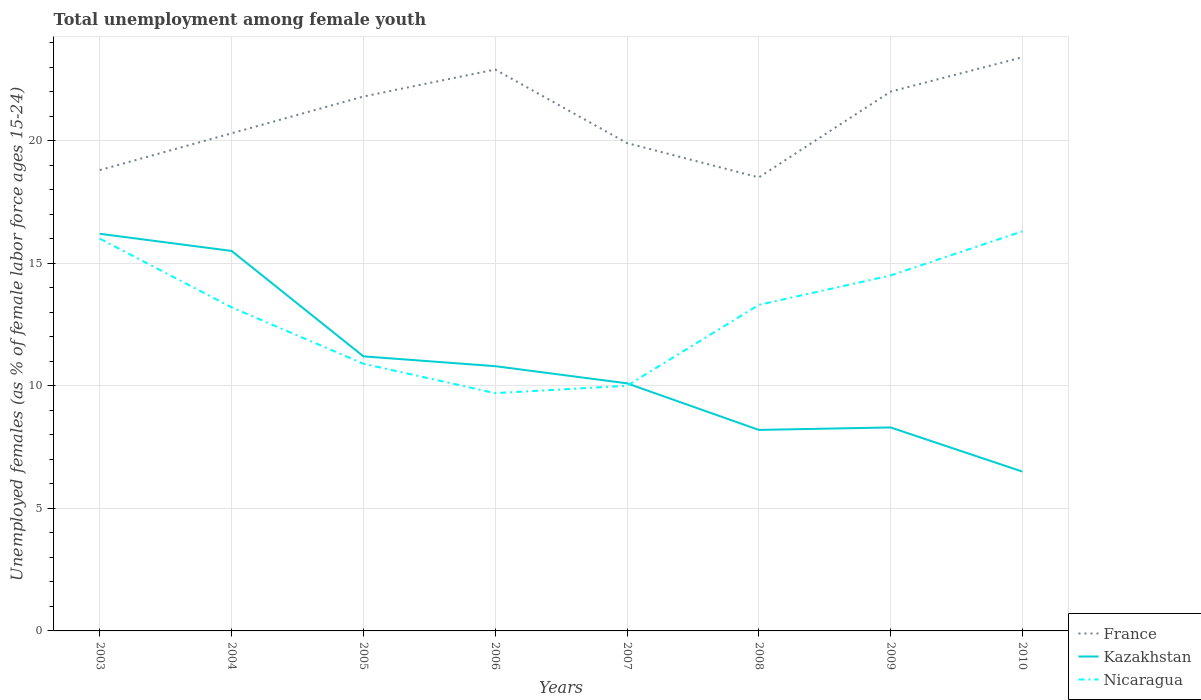How many different coloured lines are there?
Give a very brief answer. 3. In which year was the percentage of unemployed females in in Kazakhstan maximum?
Keep it short and to the point. 2010. What is the total percentage of unemployed females in in Kazakhstan in the graph?
Provide a succinct answer. 3.6. What is the difference between the highest and the second highest percentage of unemployed females in in Nicaragua?
Provide a short and direct response. 6.6. Is the percentage of unemployed females in in Nicaragua strictly greater than the percentage of unemployed females in in Kazakhstan over the years?
Make the answer very short. No. How many lines are there?
Keep it short and to the point. 3. How many years are there in the graph?
Provide a short and direct response. 8. What is the difference between two consecutive major ticks on the Y-axis?
Your answer should be compact. 5. How many legend labels are there?
Your response must be concise. 3. How are the legend labels stacked?
Provide a succinct answer. Vertical. What is the title of the graph?
Provide a succinct answer. Total unemployment among female youth. Does "High income: nonOECD" appear as one of the legend labels in the graph?
Offer a terse response. No. What is the label or title of the X-axis?
Offer a very short reply. Years. What is the label or title of the Y-axis?
Provide a succinct answer. Unemployed females (as % of female labor force ages 15-24). What is the Unemployed females (as % of female labor force ages 15-24) in France in 2003?
Offer a very short reply. 18.8. What is the Unemployed females (as % of female labor force ages 15-24) of Kazakhstan in 2003?
Keep it short and to the point. 16.2. What is the Unemployed females (as % of female labor force ages 15-24) in Nicaragua in 2003?
Your answer should be compact. 16. What is the Unemployed females (as % of female labor force ages 15-24) in France in 2004?
Your response must be concise. 20.3. What is the Unemployed females (as % of female labor force ages 15-24) in Nicaragua in 2004?
Your answer should be compact. 13.2. What is the Unemployed females (as % of female labor force ages 15-24) in France in 2005?
Offer a very short reply. 21.8. What is the Unemployed females (as % of female labor force ages 15-24) of Kazakhstan in 2005?
Provide a succinct answer. 11.2. What is the Unemployed females (as % of female labor force ages 15-24) of Nicaragua in 2005?
Offer a terse response. 10.9. What is the Unemployed females (as % of female labor force ages 15-24) in France in 2006?
Offer a terse response. 22.9. What is the Unemployed females (as % of female labor force ages 15-24) of Kazakhstan in 2006?
Your response must be concise. 10.8. What is the Unemployed females (as % of female labor force ages 15-24) in Nicaragua in 2006?
Provide a short and direct response. 9.7. What is the Unemployed females (as % of female labor force ages 15-24) of France in 2007?
Give a very brief answer. 19.9. What is the Unemployed females (as % of female labor force ages 15-24) in Kazakhstan in 2007?
Make the answer very short. 10.1. What is the Unemployed females (as % of female labor force ages 15-24) in Nicaragua in 2007?
Your answer should be compact. 10. What is the Unemployed females (as % of female labor force ages 15-24) of France in 2008?
Provide a succinct answer. 18.5. What is the Unemployed females (as % of female labor force ages 15-24) of Kazakhstan in 2008?
Your answer should be compact. 8.2. What is the Unemployed females (as % of female labor force ages 15-24) of Nicaragua in 2008?
Your answer should be very brief. 13.3. What is the Unemployed females (as % of female labor force ages 15-24) of France in 2009?
Provide a succinct answer. 22. What is the Unemployed females (as % of female labor force ages 15-24) of Kazakhstan in 2009?
Your answer should be compact. 8.3. What is the Unemployed females (as % of female labor force ages 15-24) in Nicaragua in 2009?
Your answer should be compact. 14.5. What is the Unemployed females (as % of female labor force ages 15-24) in France in 2010?
Provide a succinct answer. 23.4. What is the Unemployed females (as % of female labor force ages 15-24) of Nicaragua in 2010?
Offer a terse response. 16.3. Across all years, what is the maximum Unemployed females (as % of female labor force ages 15-24) of France?
Your response must be concise. 23.4. Across all years, what is the maximum Unemployed females (as % of female labor force ages 15-24) of Kazakhstan?
Make the answer very short. 16.2. Across all years, what is the maximum Unemployed females (as % of female labor force ages 15-24) in Nicaragua?
Your answer should be very brief. 16.3. Across all years, what is the minimum Unemployed females (as % of female labor force ages 15-24) of Kazakhstan?
Your answer should be compact. 6.5. Across all years, what is the minimum Unemployed females (as % of female labor force ages 15-24) in Nicaragua?
Provide a short and direct response. 9.7. What is the total Unemployed females (as % of female labor force ages 15-24) in France in the graph?
Keep it short and to the point. 167.6. What is the total Unemployed females (as % of female labor force ages 15-24) in Kazakhstan in the graph?
Your answer should be compact. 86.8. What is the total Unemployed females (as % of female labor force ages 15-24) in Nicaragua in the graph?
Your response must be concise. 103.9. What is the difference between the Unemployed females (as % of female labor force ages 15-24) of France in 2003 and that in 2004?
Make the answer very short. -1.5. What is the difference between the Unemployed females (as % of female labor force ages 15-24) of Nicaragua in 2003 and that in 2006?
Your answer should be compact. 6.3. What is the difference between the Unemployed females (as % of female labor force ages 15-24) of France in 2003 and that in 2007?
Provide a succinct answer. -1.1. What is the difference between the Unemployed females (as % of female labor force ages 15-24) of Nicaragua in 2003 and that in 2008?
Offer a very short reply. 2.7. What is the difference between the Unemployed females (as % of female labor force ages 15-24) of Kazakhstan in 2003 and that in 2009?
Your answer should be very brief. 7.9. What is the difference between the Unemployed females (as % of female labor force ages 15-24) of Kazakhstan in 2003 and that in 2010?
Ensure brevity in your answer.  9.7. What is the difference between the Unemployed females (as % of female labor force ages 15-24) in France in 2004 and that in 2005?
Ensure brevity in your answer.  -1.5. What is the difference between the Unemployed females (as % of female labor force ages 15-24) in Kazakhstan in 2004 and that in 2005?
Offer a very short reply. 4.3. What is the difference between the Unemployed females (as % of female labor force ages 15-24) of Nicaragua in 2004 and that in 2005?
Keep it short and to the point. 2.3. What is the difference between the Unemployed females (as % of female labor force ages 15-24) of Nicaragua in 2004 and that in 2006?
Give a very brief answer. 3.5. What is the difference between the Unemployed females (as % of female labor force ages 15-24) in France in 2004 and that in 2007?
Your answer should be very brief. 0.4. What is the difference between the Unemployed females (as % of female labor force ages 15-24) in Nicaragua in 2004 and that in 2007?
Provide a short and direct response. 3.2. What is the difference between the Unemployed females (as % of female labor force ages 15-24) of France in 2004 and that in 2008?
Ensure brevity in your answer.  1.8. What is the difference between the Unemployed females (as % of female labor force ages 15-24) in Kazakhstan in 2004 and that in 2009?
Provide a succinct answer. 7.2. What is the difference between the Unemployed females (as % of female labor force ages 15-24) in Kazakhstan in 2005 and that in 2006?
Provide a short and direct response. 0.4. What is the difference between the Unemployed females (as % of female labor force ages 15-24) of Nicaragua in 2005 and that in 2006?
Provide a succinct answer. 1.2. What is the difference between the Unemployed females (as % of female labor force ages 15-24) in Kazakhstan in 2005 and that in 2008?
Keep it short and to the point. 3. What is the difference between the Unemployed females (as % of female labor force ages 15-24) in Nicaragua in 2005 and that in 2008?
Offer a very short reply. -2.4. What is the difference between the Unemployed females (as % of female labor force ages 15-24) of Kazakhstan in 2005 and that in 2009?
Give a very brief answer. 2.9. What is the difference between the Unemployed females (as % of female labor force ages 15-24) in Nicaragua in 2005 and that in 2009?
Give a very brief answer. -3.6. What is the difference between the Unemployed females (as % of female labor force ages 15-24) of Kazakhstan in 2006 and that in 2007?
Give a very brief answer. 0.7. What is the difference between the Unemployed females (as % of female labor force ages 15-24) of France in 2006 and that in 2008?
Provide a short and direct response. 4.4. What is the difference between the Unemployed females (as % of female labor force ages 15-24) in Kazakhstan in 2006 and that in 2008?
Your response must be concise. 2.6. What is the difference between the Unemployed females (as % of female labor force ages 15-24) in Nicaragua in 2006 and that in 2008?
Provide a succinct answer. -3.6. What is the difference between the Unemployed females (as % of female labor force ages 15-24) of Kazakhstan in 2006 and that in 2010?
Provide a succinct answer. 4.3. What is the difference between the Unemployed females (as % of female labor force ages 15-24) in France in 2007 and that in 2009?
Provide a short and direct response. -2.1. What is the difference between the Unemployed females (as % of female labor force ages 15-24) in Kazakhstan in 2007 and that in 2009?
Your response must be concise. 1.8. What is the difference between the Unemployed females (as % of female labor force ages 15-24) in Nicaragua in 2007 and that in 2009?
Make the answer very short. -4.5. What is the difference between the Unemployed females (as % of female labor force ages 15-24) of France in 2007 and that in 2010?
Provide a short and direct response. -3.5. What is the difference between the Unemployed females (as % of female labor force ages 15-24) of France in 2008 and that in 2009?
Provide a succinct answer. -3.5. What is the difference between the Unemployed females (as % of female labor force ages 15-24) in Nicaragua in 2008 and that in 2009?
Your answer should be very brief. -1.2. What is the difference between the Unemployed females (as % of female labor force ages 15-24) of Nicaragua in 2008 and that in 2010?
Offer a terse response. -3. What is the difference between the Unemployed females (as % of female labor force ages 15-24) in Nicaragua in 2009 and that in 2010?
Your response must be concise. -1.8. What is the difference between the Unemployed females (as % of female labor force ages 15-24) of France in 2003 and the Unemployed females (as % of female labor force ages 15-24) of Kazakhstan in 2005?
Your answer should be very brief. 7.6. What is the difference between the Unemployed females (as % of female labor force ages 15-24) in Kazakhstan in 2003 and the Unemployed females (as % of female labor force ages 15-24) in Nicaragua in 2005?
Your answer should be compact. 5.3. What is the difference between the Unemployed females (as % of female labor force ages 15-24) in France in 2003 and the Unemployed females (as % of female labor force ages 15-24) in Kazakhstan in 2006?
Provide a short and direct response. 8. What is the difference between the Unemployed females (as % of female labor force ages 15-24) of France in 2003 and the Unemployed females (as % of female labor force ages 15-24) of Nicaragua in 2006?
Give a very brief answer. 9.1. What is the difference between the Unemployed females (as % of female labor force ages 15-24) in France in 2003 and the Unemployed females (as % of female labor force ages 15-24) in Kazakhstan in 2008?
Your answer should be very brief. 10.6. What is the difference between the Unemployed females (as % of female labor force ages 15-24) in France in 2003 and the Unemployed females (as % of female labor force ages 15-24) in Kazakhstan in 2009?
Your answer should be very brief. 10.5. What is the difference between the Unemployed females (as % of female labor force ages 15-24) of France in 2004 and the Unemployed females (as % of female labor force ages 15-24) of Nicaragua in 2005?
Keep it short and to the point. 9.4. What is the difference between the Unemployed females (as % of female labor force ages 15-24) in Kazakhstan in 2004 and the Unemployed females (as % of female labor force ages 15-24) in Nicaragua in 2005?
Provide a short and direct response. 4.6. What is the difference between the Unemployed females (as % of female labor force ages 15-24) in France in 2004 and the Unemployed females (as % of female labor force ages 15-24) in Kazakhstan in 2006?
Ensure brevity in your answer.  9.5. What is the difference between the Unemployed females (as % of female labor force ages 15-24) in France in 2004 and the Unemployed females (as % of female labor force ages 15-24) in Nicaragua in 2008?
Provide a short and direct response. 7. What is the difference between the Unemployed females (as % of female labor force ages 15-24) of Kazakhstan in 2004 and the Unemployed females (as % of female labor force ages 15-24) of Nicaragua in 2008?
Keep it short and to the point. 2.2. What is the difference between the Unemployed females (as % of female labor force ages 15-24) in France in 2004 and the Unemployed females (as % of female labor force ages 15-24) in Kazakhstan in 2009?
Your answer should be compact. 12. What is the difference between the Unemployed females (as % of female labor force ages 15-24) of France in 2004 and the Unemployed females (as % of female labor force ages 15-24) of Kazakhstan in 2010?
Make the answer very short. 13.8. What is the difference between the Unemployed females (as % of female labor force ages 15-24) of France in 2004 and the Unemployed females (as % of female labor force ages 15-24) of Nicaragua in 2010?
Provide a short and direct response. 4. What is the difference between the Unemployed females (as % of female labor force ages 15-24) in France in 2005 and the Unemployed females (as % of female labor force ages 15-24) in Kazakhstan in 2006?
Ensure brevity in your answer.  11. What is the difference between the Unemployed females (as % of female labor force ages 15-24) in Kazakhstan in 2005 and the Unemployed females (as % of female labor force ages 15-24) in Nicaragua in 2006?
Provide a short and direct response. 1.5. What is the difference between the Unemployed females (as % of female labor force ages 15-24) of Kazakhstan in 2005 and the Unemployed females (as % of female labor force ages 15-24) of Nicaragua in 2007?
Ensure brevity in your answer.  1.2. What is the difference between the Unemployed females (as % of female labor force ages 15-24) of France in 2005 and the Unemployed females (as % of female labor force ages 15-24) of Nicaragua in 2008?
Ensure brevity in your answer.  8.5. What is the difference between the Unemployed females (as % of female labor force ages 15-24) of Kazakhstan in 2005 and the Unemployed females (as % of female labor force ages 15-24) of Nicaragua in 2008?
Your answer should be very brief. -2.1. What is the difference between the Unemployed females (as % of female labor force ages 15-24) of France in 2005 and the Unemployed females (as % of female labor force ages 15-24) of Nicaragua in 2009?
Make the answer very short. 7.3. What is the difference between the Unemployed females (as % of female labor force ages 15-24) of France in 2006 and the Unemployed females (as % of female labor force ages 15-24) of Kazakhstan in 2007?
Offer a terse response. 12.8. What is the difference between the Unemployed females (as % of female labor force ages 15-24) of France in 2006 and the Unemployed females (as % of female labor force ages 15-24) of Nicaragua in 2008?
Make the answer very short. 9.6. What is the difference between the Unemployed females (as % of female labor force ages 15-24) in Kazakhstan in 2006 and the Unemployed females (as % of female labor force ages 15-24) in Nicaragua in 2008?
Offer a terse response. -2.5. What is the difference between the Unemployed females (as % of female labor force ages 15-24) of France in 2006 and the Unemployed females (as % of female labor force ages 15-24) of Nicaragua in 2009?
Make the answer very short. 8.4. What is the difference between the Unemployed females (as % of female labor force ages 15-24) of Kazakhstan in 2006 and the Unemployed females (as % of female labor force ages 15-24) of Nicaragua in 2009?
Your response must be concise. -3.7. What is the difference between the Unemployed females (as % of female labor force ages 15-24) of Kazakhstan in 2006 and the Unemployed females (as % of female labor force ages 15-24) of Nicaragua in 2010?
Offer a very short reply. -5.5. What is the difference between the Unemployed females (as % of female labor force ages 15-24) of France in 2007 and the Unemployed females (as % of female labor force ages 15-24) of Nicaragua in 2008?
Your answer should be very brief. 6.6. What is the difference between the Unemployed females (as % of female labor force ages 15-24) in France in 2007 and the Unemployed females (as % of female labor force ages 15-24) in Kazakhstan in 2009?
Ensure brevity in your answer.  11.6. What is the difference between the Unemployed females (as % of female labor force ages 15-24) in France in 2007 and the Unemployed females (as % of female labor force ages 15-24) in Nicaragua in 2010?
Your answer should be very brief. 3.6. What is the difference between the Unemployed females (as % of female labor force ages 15-24) of Kazakhstan in 2008 and the Unemployed females (as % of female labor force ages 15-24) of Nicaragua in 2009?
Your response must be concise. -6.3. What is the difference between the Unemployed females (as % of female labor force ages 15-24) in France in 2008 and the Unemployed females (as % of female labor force ages 15-24) in Kazakhstan in 2010?
Ensure brevity in your answer.  12. What is the difference between the Unemployed females (as % of female labor force ages 15-24) of France in 2009 and the Unemployed females (as % of female labor force ages 15-24) of Nicaragua in 2010?
Provide a short and direct response. 5.7. What is the difference between the Unemployed females (as % of female labor force ages 15-24) of Kazakhstan in 2009 and the Unemployed females (as % of female labor force ages 15-24) of Nicaragua in 2010?
Offer a terse response. -8. What is the average Unemployed females (as % of female labor force ages 15-24) of France per year?
Offer a terse response. 20.95. What is the average Unemployed females (as % of female labor force ages 15-24) of Kazakhstan per year?
Provide a short and direct response. 10.85. What is the average Unemployed females (as % of female labor force ages 15-24) in Nicaragua per year?
Your response must be concise. 12.99. In the year 2003, what is the difference between the Unemployed females (as % of female labor force ages 15-24) of France and Unemployed females (as % of female labor force ages 15-24) of Nicaragua?
Keep it short and to the point. 2.8. In the year 2004, what is the difference between the Unemployed females (as % of female labor force ages 15-24) in France and Unemployed females (as % of female labor force ages 15-24) in Nicaragua?
Your answer should be compact. 7.1. In the year 2005, what is the difference between the Unemployed females (as % of female labor force ages 15-24) of France and Unemployed females (as % of female labor force ages 15-24) of Nicaragua?
Your answer should be compact. 10.9. In the year 2005, what is the difference between the Unemployed females (as % of female labor force ages 15-24) of Kazakhstan and Unemployed females (as % of female labor force ages 15-24) of Nicaragua?
Your answer should be compact. 0.3. In the year 2006, what is the difference between the Unemployed females (as % of female labor force ages 15-24) in Kazakhstan and Unemployed females (as % of female labor force ages 15-24) in Nicaragua?
Keep it short and to the point. 1.1. In the year 2007, what is the difference between the Unemployed females (as % of female labor force ages 15-24) of France and Unemployed females (as % of female labor force ages 15-24) of Nicaragua?
Give a very brief answer. 9.9. In the year 2008, what is the difference between the Unemployed females (as % of female labor force ages 15-24) in France and Unemployed females (as % of female labor force ages 15-24) in Nicaragua?
Keep it short and to the point. 5.2. In the year 2009, what is the difference between the Unemployed females (as % of female labor force ages 15-24) in France and Unemployed females (as % of female labor force ages 15-24) in Kazakhstan?
Offer a terse response. 13.7. In the year 2009, what is the difference between the Unemployed females (as % of female labor force ages 15-24) in Kazakhstan and Unemployed females (as % of female labor force ages 15-24) in Nicaragua?
Keep it short and to the point. -6.2. In the year 2010, what is the difference between the Unemployed females (as % of female labor force ages 15-24) in France and Unemployed females (as % of female labor force ages 15-24) in Kazakhstan?
Make the answer very short. 16.9. In the year 2010, what is the difference between the Unemployed females (as % of female labor force ages 15-24) in France and Unemployed females (as % of female labor force ages 15-24) in Nicaragua?
Make the answer very short. 7.1. In the year 2010, what is the difference between the Unemployed females (as % of female labor force ages 15-24) in Kazakhstan and Unemployed females (as % of female labor force ages 15-24) in Nicaragua?
Your response must be concise. -9.8. What is the ratio of the Unemployed females (as % of female labor force ages 15-24) in France in 2003 to that in 2004?
Provide a short and direct response. 0.93. What is the ratio of the Unemployed females (as % of female labor force ages 15-24) in Kazakhstan in 2003 to that in 2004?
Give a very brief answer. 1.05. What is the ratio of the Unemployed females (as % of female labor force ages 15-24) in Nicaragua in 2003 to that in 2004?
Provide a succinct answer. 1.21. What is the ratio of the Unemployed females (as % of female labor force ages 15-24) in France in 2003 to that in 2005?
Your answer should be very brief. 0.86. What is the ratio of the Unemployed females (as % of female labor force ages 15-24) in Kazakhstan in 2003 to that in 2005?
Make the answer very short. 1.45. What is the ratio of the Unemployed females (as % of female labor force ages 15-24) in Nicaragua in 2003 to that in 2005?
Keep it short and to the point. 1.47. What is the ratio of the Unemployed females (as % of female labor force ages 15-24) in France in 2003 to that in 2006?
Offer a very short reply. 0.82. What is the ratio of the Unemployed females (as % of female labor force ages 15-24) of Nicaragua in 2003 to that in 2006?
Give a very brief answer. 1.65. What is the ratio of the Unemployed females (as % of female labor force ages 15-24) in France in 2003 to that in 2007?
Offer a very short reply. 0.94. What is the ratio of the Unemployed females (as % of female labor force ages 15-24) in Kazakhstan in 2003 to that in 2007?
Your answer should be very brief. 1.6. What is the ratio of the Unemployed females (as % of female labor force ages 15-24) of France in 2003 to that in 2008?
Provide a succinct answer. 1.02. What is the ratio of the Unemployed females (as % of female labor force ages 15-24) of Kazakhstan in 2003 to that in 2008?
Keep it short and to the point. 1.98. What is the ratio of the Unemployed females (as % of female labor force ages 15-24) of Nicaragua in 2003 to that in 2008?
Offer a very short reply. 1.2. What is the ratio of the Unemployed females (as % of female labor force ages 15-24) in France in 2003 to that in 2009?
Keep it short and to the point. 0.85. What is the ratio of the Unemployed females (as % of female labor force ages 15-24) in Kazakhstan in 2003 to that in 2009?
Provide a succinct answer. 1.95. What is the ratio of the Unemployed females (as % of female labor force ages 15-24) of Nicaragua in 2003 to that in 2009?
Offer a very short reply. 1.1. What is the ratio of the Unemployed females (as % of female labor force ages 15-24) in France in 2003 to that in 2010?
Offer a very short reply. 0.8. What is the ratio of the Unemployed females (as % of female labor force ages 15-24) of Kazakhstan in 2003 to that in 2010?
Make the answer very short. 2.49. What is the ratio of the Unemployed females (as % of female labor force ages 15-24) in Nicaragua in 2003 to that in 2010?
Your response must be concise. 0.98. What is the ratio of the Unemployed females (as % of female labor force ages 15-24) of France in 2004 to that in 2005?
Offer a terse response. 0.93. What is the ratio of the Unemployed females (as % of female labor force ages 15-24) in Kazakhstan in 2004 to that in 2005?
Give a very brief answer. 1.38. What is the ratio of the Unemployed females (as % of female labor force ages 15-24) in Nicaragua in 2004 to that in 2005?
Your response must be concise. 1.21. What is the ratio of the Unemployed females (as % of female labor force ages 15-24) of France in 2004 to that in 2006?
Ensure brevity in your answer.  0.89. What is the ratio of the Unemployed females (as % of female labor force ages 15-24) in Kazakhstan in 2004 to that in 2006?
Provide a short and direct response. 1.44. What is the ratio of the Unemployed females (as % of female labor force ages 15-24) of Nicaragua in 2004 to that in 2006?
Offer a terse response. 1.36. What is the ratio of the Unemployed females (as % of female labor force ages 15-24) in France in 2004 to that in 2007?
Offer a very short reply. 1.02. What is the ratio of the Unemployed females (as % of female labor force ages 15-24) in Kazakhstan in 2004 to that in 2007?
Provide a succinct answer. 1.53. What is the ratio of the Unemployed females (as % of female labor force ages 15-24) of Nicaragua in 2004 to that in 2007?
Your answer should be very brief. 1.32. What is the ratio of the Unemployed females (as % of female labor force ages 15-24) in France in 2004 to that in 2008?
Your response must be concise. 1.1. What is the ratio of the Unemployed females (as % of female labor force ages 15-24) in Kazakhstan in 2004 to that in 2008?
Give a very brief answer. 1.89. What is the ratio of the Unemployed females (as % of female labor force ages 15-24) of Nicaragua in 2004 to that in 2008?
Your answer should be very brief. 0.99. What is the ratio of the Unemployed females (as % of female labor force ages 15-24) in France in 2004 to that in 2009?
Your answer should be very brief. 0.92. What is the ratio of the Unemployed females (as % of female labor force ages 15-24) in Kazakhstan in 2004 to that in 2009?
Your answer should be compact. 1.87. What is the ratio of the Unemployed females (as % of female labor force ages 15-24) in Nicaragua in 2004 to that in 2009?
Offer a terse response. 0.91. What is the ratio of the Unemployed females (as % of female labor force ages 15-24) of France in 2004 to that in 2010?
Your answer should be very brief. 0.87. What is the ratio of the Unemployed females (as % of female labor force ages 15-24) in Kazakhstan in 2004 to that in 2010?
Your answer should be very brief. 2.38. What is the ratio of the Unemployed females (as % of female labor force ages 15-24) in Nicaragua in 2004 to that in 2010?
Offer a very short reply. 0.81. What is the ratio of the Unemployed females (as % of female labor force ages 15-24) in France in 2005 to that in 2006?
Your response must be concise. 0.95. What is the ratio of the Unemployed females (as % of female labor force ages 15-24) in Kazakhstan in 2005 to that in 2006?
Make the answer very short. 1.04. What is the ratio of the Unemployed females (as % of female labor force ages 15-24) in Nicaragua in 2005 to that in 2006?
Make the answer very short. 1.12. What is the ratio of the Unemployed females (as % of female labor force ages 15-24) in France in 2005 to that in 2007?
Your response must be concise. 1.1. What is the ratio of the Unemployed females (as % of female labor force ages 15-24) of Kazakhstan in 2005 to that in 2007?
Keep it short and to the point. 1.11. What is the ratio of the Unemployed females (as % of female labor force ages 15-24) in Nicaragua in 2005 to that in 2007?
Provide a short and direct response. 1.09. What is the ratio of the Unemployed females (as % of female labor force ages 15-24) in France in 2005 to that in 2008?
Your answer should be very brief. 1.18. What is the ratio of the Unemployed females (as % of female labor force ages 15-24) in Kazakhstan in 2005 to that in 2008?
Make the answer very short. 1.37. What is the ratio of the Unemployed females (as % of female labor force ages 15-24) of Nicaragua in 2005 to that in 2008?
Your response must be concise. 0.82. What is the ratio of the Unemployed females (as % of female labor force ages 15-24) of France in 2005 to that in 2009?
Your response must be concise. 0.99. What is the ratio of the Unemployed females (as % of female labor force ages 15-24) of Kazakhstan in 2005 to that in 2009?
Offer a terse response. 1.35. What is the ratio of the Unemployed females (as % of female labor force ages 15-24) of Nicaragua in 2005 to that in 2009?
Offer a very short reply. 0.75. What is the ratio of the Unemployed females (as % of female labor force ages 15-24) in France in 2005 to that in 2010?
Your response must be concise. 0.93. What is the ratio of the Unemployed females (as % of female labor force ages 15-24) in Kazakhstan in 2005 to that in 2010?
Give a very brief answer. 1.72. What is the ratio of the Unemployed females (as % of female labor force ages 15-24) of Nicaragua in 2005 to that in 2010?
Your answer should be compact. 0.67. What is the ratio of the Unemployed females (as % of female labor force ages 15-24) in France in 2006 to that in 2007?
Keep it short and to the point. 1.15. What is the ratio of the Unemployed females (as % of female labor force ages 15-24) of Kazakhstan in 2006 to that in 2007?
Make the answer very short. 1.07. What is the ratio of the Unemployed females (as % of female labor force ages 15-24) of France in 2006 to that in 2008?
Your answer should be very brief. 1.24. What is the ratio of the Unemployed females (as % of female labor force ages 15-24) in Kazakhstan in 2006 to that in 2008?
Provide a short and direct response. 1.32. What is the ratio of the Unemployed females (as % of female labor force ages 15-24) of Nicaragua in 2006 to that in 2008?
Provide a short and direct response. 0.73. What is the ratio of the Unemployed females (as % of female labor force ages 15-24) in France in 2006 to that in 2009?
Your answer should be compact. 1.04. What is the ratio of the Unemployed females (as % of female labor force ages 15-24) of Kazakhstan in 2006 to that in 2009?
Make the answer very short. 1.3. What is the ratio of the Unemployed females (as % of female labor force ages 15-24) in Nicaragua in 2006 to that in 2009?
Give a very brief answer. 0.67. What is the ratio of the Unemployed females (as % of female labor force ages 15-24) in France in 2006 to that in 2010?
Give a very brief answer. 0.98. What is the ratio of the Unemployed females (as % of female labor force ages 15-24) in Kazakhstan in 2006 to that in 2010?
Your answer should be compact. 1.66. What is the ratio of the Unemployed females (as % of female labor force ages 15-24) of Nicaragua in 2006 to that in 2010?
Provide a short and direct response. 0.6. What is the ratio of the Unemployed females (as % of female labor force ages 15-24) of France in 2007 to that in 2008?
Provide a succinct answer. 1.08. What is the ratio of the Unemployed females (as % of female labor force ages 15-24) of Kazakhstan in 2007 to that in 2008?
Ensure brevity in your answer.  1.23. What is the ratio of the Unemployed females (as % of female labor force ages 15-24) in Nicaragua in 2007 to that in 2008?
Provide a succinct answer. 0.75. What is the ratio of the Unemployed females (as % of female labor force ages 15-24) of France in 2007 to that in 2009?
Your answer should be very brief. 0.9. What is the ratio of the Unemployed females (as % of female labor force ages 15-24) in Kazakhstan in 2007 to that in 2009?
Keep it short and to the point. 1.22. What is the ratio of the Unemployed females (as % of female labor force ages 15-24) in Nicaragua in 2007 to that in 2009?
Provide a short and direct response. 0.69. What is the ratio of the Unemployed females (as % of female labor force ages 15-24) of France in 2007 to that in 2010?
Keep it short and to the point. 0.85. What is the ratio of the Unemployed females (as % of female labor force ages 15-24) of Kazakhstan in 2007 to that in 2010?
Give a very brief answer. 1.55. What is the ratio of the Unemployed females (as % of female labor force ages 15-24) of Nicaragua in 2007 to that in 2010?
Offer a terse response. 0.61. What is the ratio of the Unemployed females (as % of female labor force ages 15-24) of France in 2008 to that in 2009?
Your answer should be compact. 0.84. What is the ratio of the Unemployed females (as % of female labor force ages 15-24) in Nicaragua in 2008 to that in 2009?
Give a very brief answer. 0.92. What is the ratio of the Unemployed females (as % of female labor force ages 15-24) of France in 2008 to that in 2010?
Make the answer very short. 0.79. What is the ratio of the Unemployed females (as % of female labor force ages 15-24) of Kazakhstan in 2008 to that in 2010?
Offer a very short reply. 1.26. What is the ratio of the Unemployed females (as % of female labor force ages 15-24) of Nicaragua in 2008 to that in 2010?
Provide a succinct answer. 0.82. What is the ratio of the Unemployed females (as % of female labor force ages 15-24) in France in 2009 to that in 2010?
Offer a very short reply. 0.94. What is the ratio of the Unemployed females (as % of female labor force ages 15-24) of Kazakhstan in 2009 to that in 2010?
Provide a short and direct response. 1.28. What is the ratio of the Unemployed females (as % of female labor force ages 15-24) of Nicaragua in 2009 to that in 2010?
Your response must be concise. 0.89. What is the difference between the highest and the second highest Unemployed females (as % of female labor force ages 15-24) of France?
Your response must be concise. 0.5. What is the difference between the highest and the second highest Unemployed females (as % of female labor force ages 15-24) of Nicaragua?
Offer a very short reply. 0.3. What is the difference between the highest and the lowest Unemployed females (as % of female labor force ages 15-24) of Kazakhstan?
Your answer should be compact. 9.7. What is the difference between the highest and the lowest Unemployed females (as % of female labor force ages 15-24) in Nicaragua?
Your answer should be compact. 6.6. 